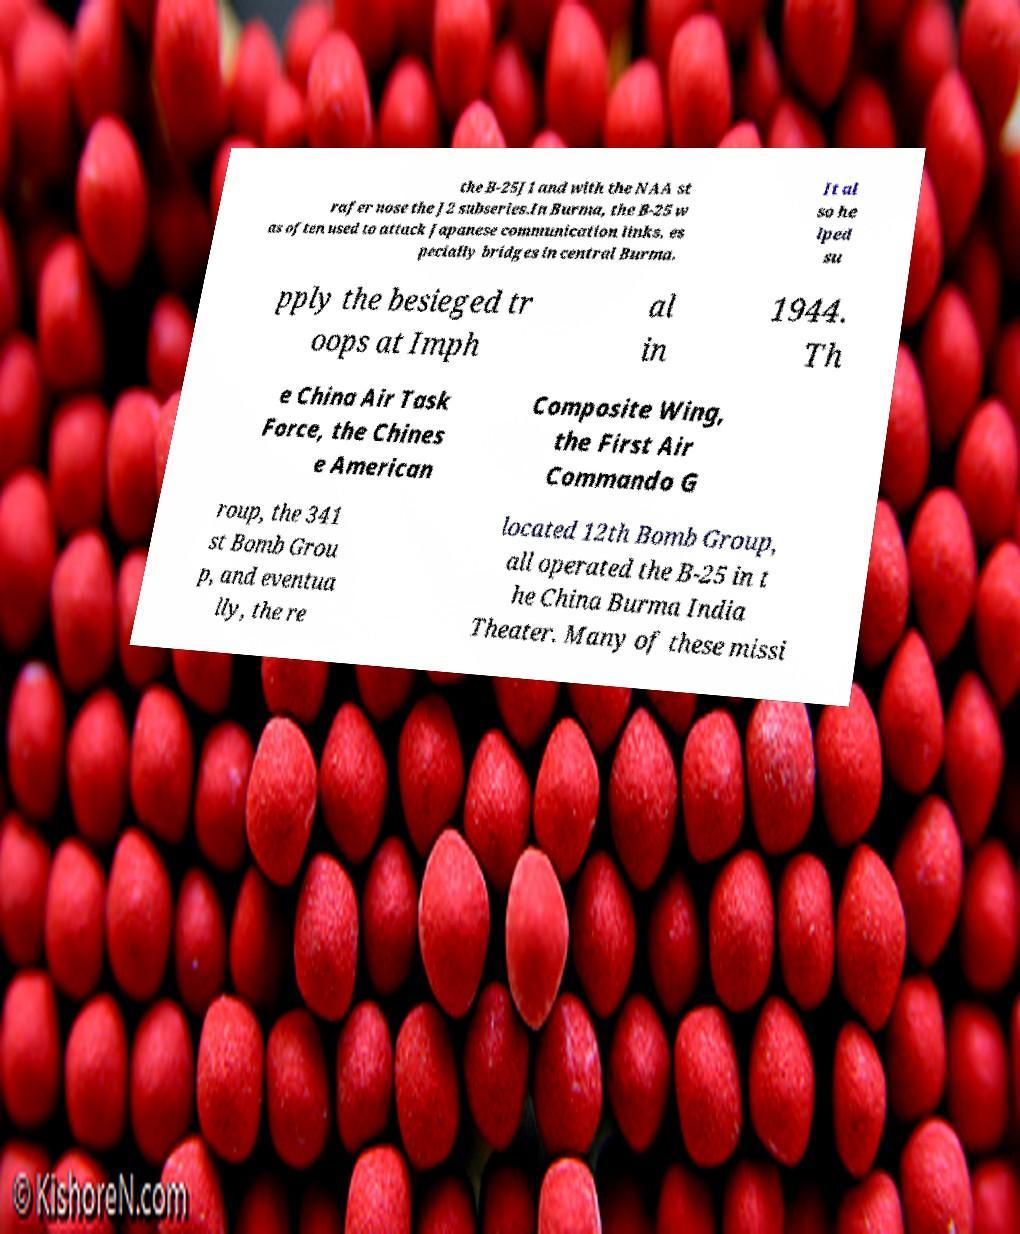Can you read and provide the text displayed in the image?This photo seems to have some interesting text. Can you extract and type it out for me? the B-25J1 and with the NAA st rafer nose the J2 subseries.In Burma, the B-25 w as often used to attack Japanese communication links, es pecially bridges in central Burma. It al so he lped su pply the besieged tr oops at Imph al in 1944. Th e China Air Task Force, the Chines e American Composite Wing, the First Air Commando G roup, the 341 st Bomb Grou p, and eventua lly, the re located 12th Bomb Group, all operated the B-25 in t he China Burma India Theater. Many of these missi 